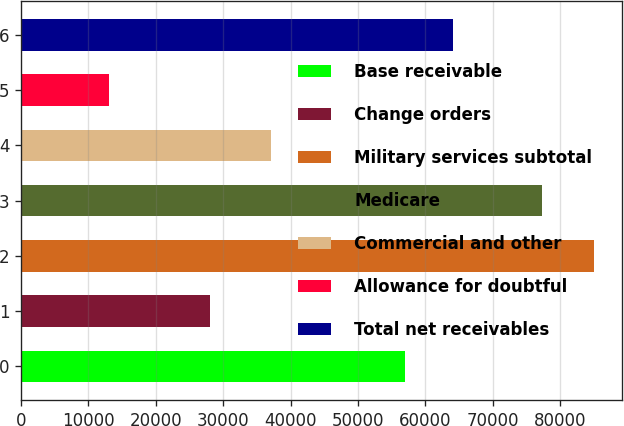Convert chart to OTSL. <chart><loc_0><loc_0><loc_500><loc_500><bar_chart><fcel>Base receivable<fcel>Change orders<fcel>Military services subtotal<fcel>Medicare<fcel>Commercial and other<fcel>Allowance for doubtful<fcel>Total net receivables<nl><fcel>56935<fcel>28038<fcel>84973<fcel>77339<fcel>37045<fcel>13032<fcel>64129.1<nl></chart> 